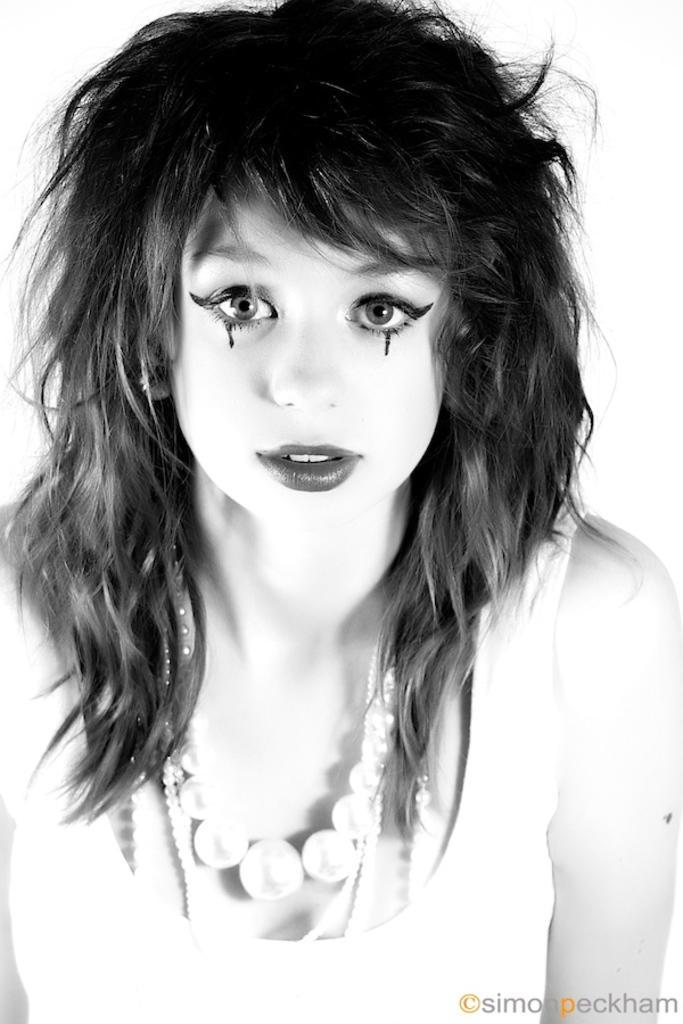Please provide a concise description of this image. This is a black and white image. In the image there is a lady with pearls chain around neck. Below her eyes there is a black color mark. At the bottom of the image there is a watermark. 